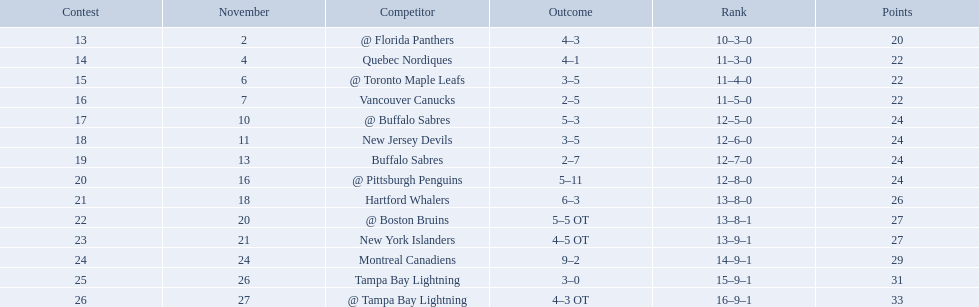Who did the philadelphia flyers play in game 17? @ Buffalo Sabres. What was the score of the november 10th game against the buffalo sabres? 5–3. Which team in the atlantic division had less points than the philadelphia flyers? Tampa Bay Lightning. Which teams scored 35 points or more in total? Hartford Whalers, @ Boston Bruins, New York Islanders, Montreal Canadiens, Tampa Bay Lightning, @ Tampa Bay Lightning. Of those teams, which team was the only one to score 3-0? Tampa Bay Lightning. 